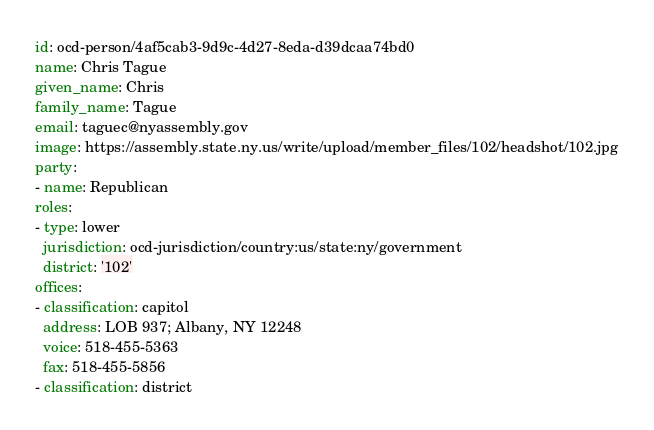Convert code to text. <code><loc_0><loc_0><loc_500><loc_500><_YAML_>id: ocd-person/4af5cab3-9d9c-4d27-8eda-d39dcaa74bd0
name: Chris Tague
given_name: Chris
family_name: Tague
email: taguec@nyassembly.gov
image: https://assembly.state.ny.us/write/upload/member_files/102/headshot/102.jpg
party:
- name: Republican
roles:
- type: lower
  jurisdiction: ocd-jurisdiction/country:us/state:ny/government
  district: '102'
offices:
- classification: capitol
  address: LOB 937; Albany, NY 12248
  voice: 518-455-5363
  fax: 518-455-5856
- classification: district</code> 